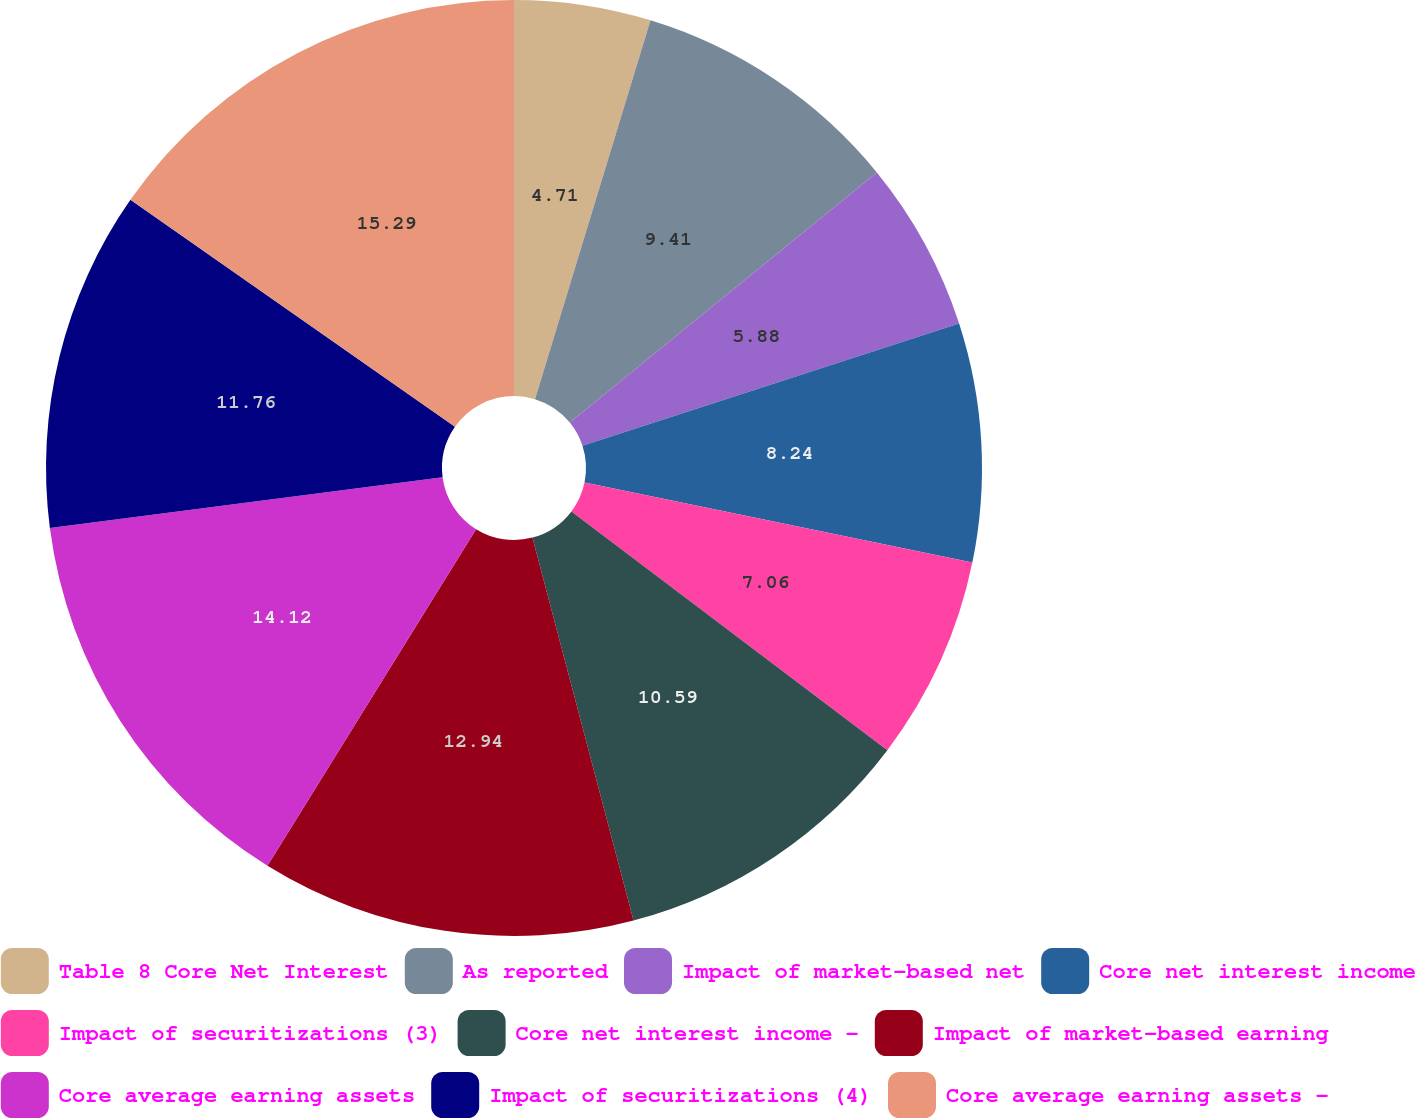Convert chart to OTSL. <chart><loc_0><loc_0><loc_500><loc_500><pie_chart><fcel>Table 8 Core Net Interest<fcel>As reported<fcel>Impact of market-based net<fcel>Core net interest income<fcel>Impact of securitizations (3)<fcel>Core net interest income -<fcel>Impact of market-based earning<fcel>Core average earning assets<fcel>Impact of securitizations (4)<fcel>Core average earning assets -<nl><fcel>4.71%<fcel>9.41%<fcel>5.88%<fcel>8.24%<fcel>7.06%<fcel>10.59%<fcel>12.94%<fcel>14.12%<fcel>11.76%<fcel>15.29%<nl></chart> 